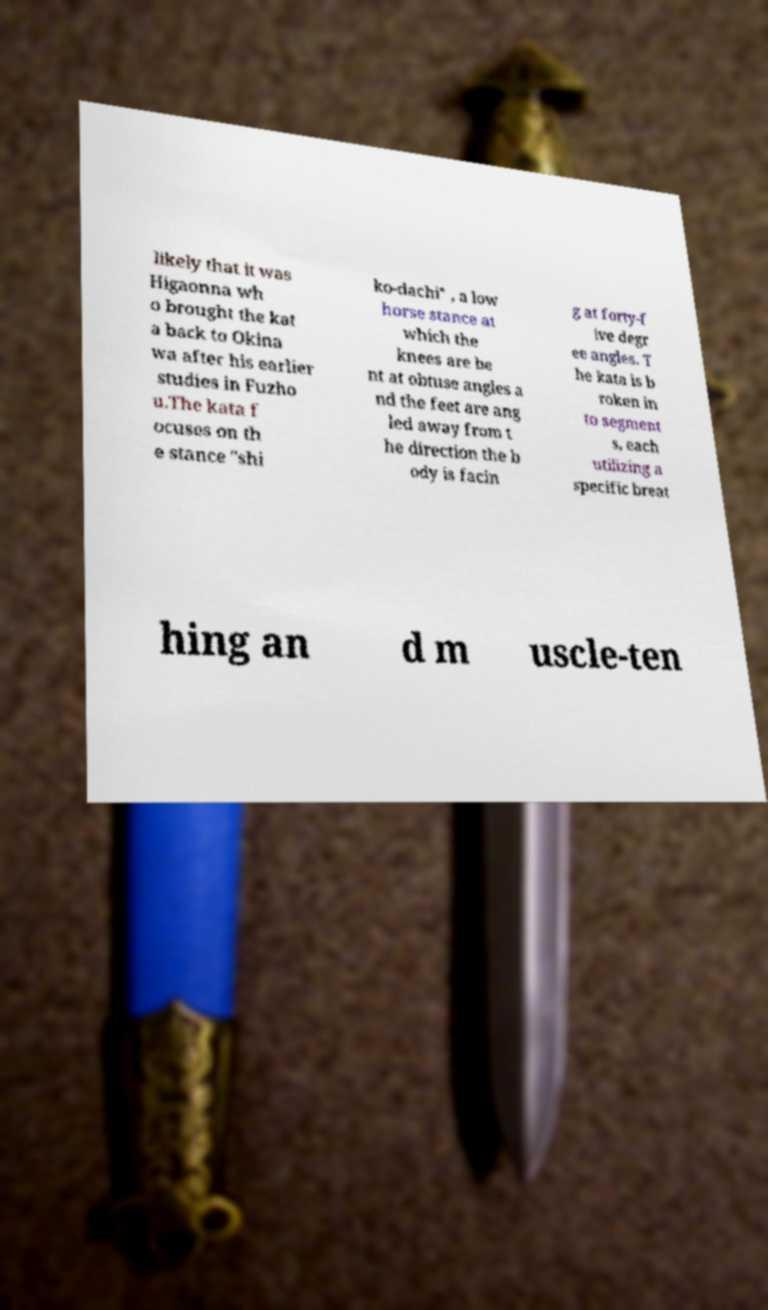Can you accurately transcribe the text from the provided image for me? likely that it was Higaonna wh o brought the kat a back to Okina wa after his earlier studies in Fuzho u.The kata f ocuses on th e stance "shi ko-dachi" , a low horse stance at which the knees are be nt at obtuse angles a nd the feet are ang led away from t he direction the b ody is facin g at forty-f ive degr ee angles. T he kata is b roken in to segment s, each utilizing a specific breat hing an d m uscle-ten 